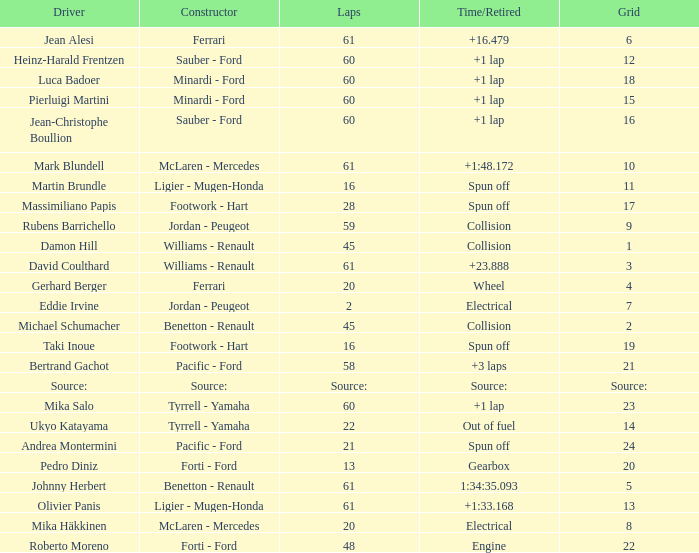How many laps does jean-christophe boullion have with a time/retired of +1 lap? 60.0. 